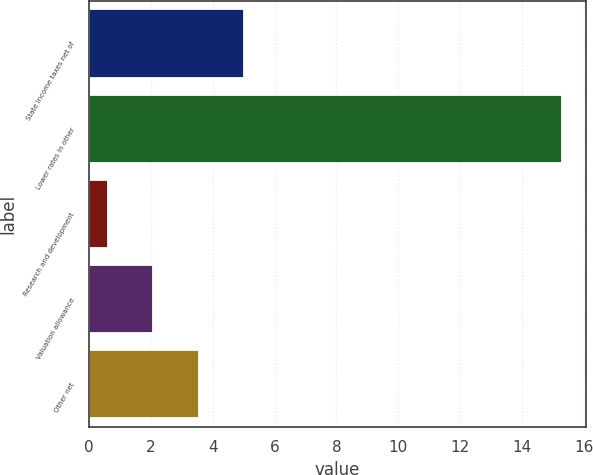Convert chart. <chart><loc_0><loc_0><loc_500><loc_500><bar_chart><fcel>State income taxes net of<fcel>Lower rates in other<fcel>Research and development<fcel>Valuation allowance<fcel>Other net<nl><fcel>5.01<fcel>15.3<fcel>0.6<fcel>2.07<fcel>3.54<nl></chart> 